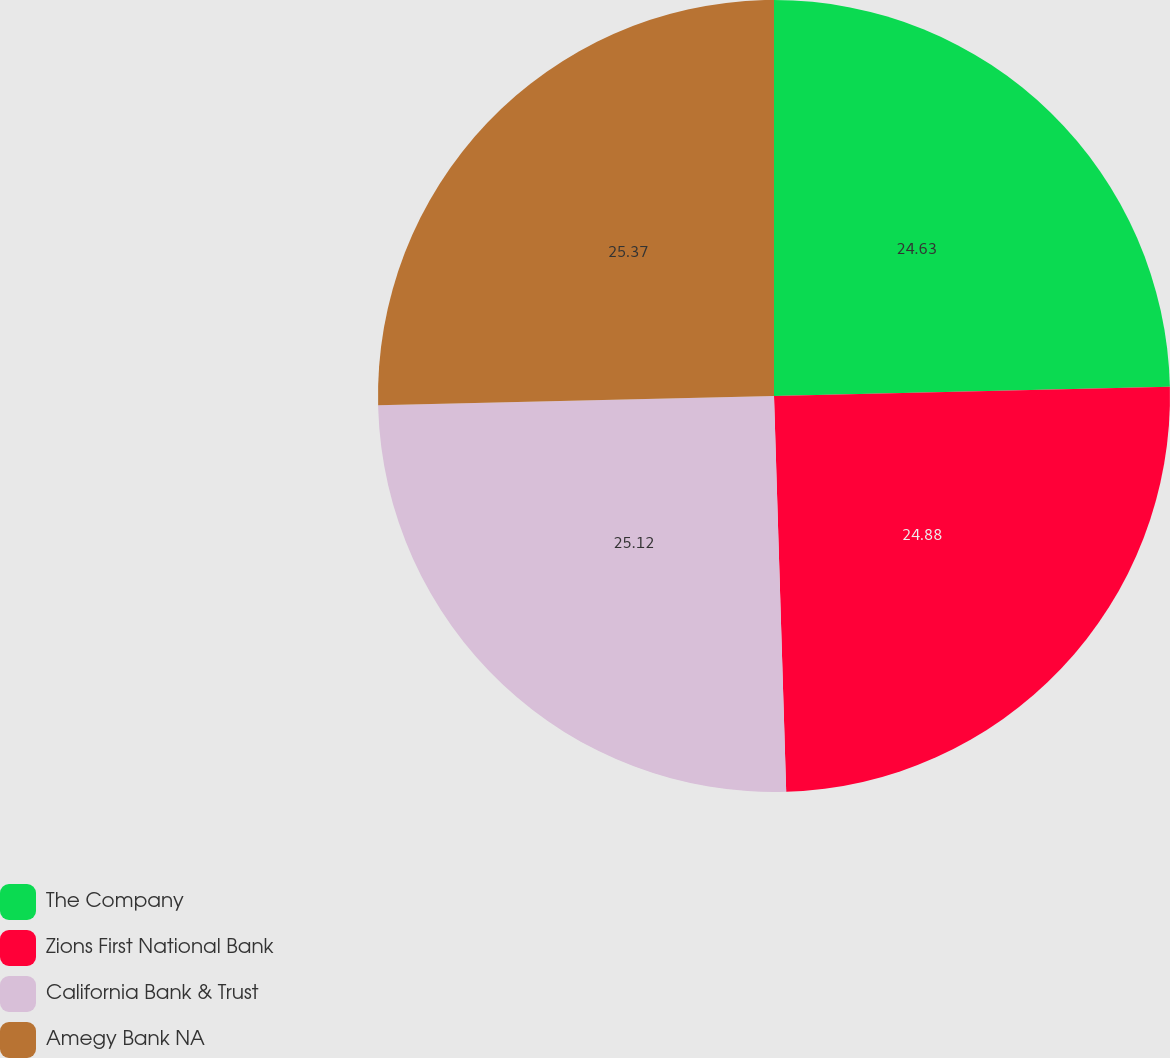Convert chart. <chart><loc_0><loc_0><loc_500><loc_500><pie_chart><fcel>The Company<fcel>Zions First National Bank<fcel>California Bank & Trust<fcel>Amegy Bank NA<nl><fcel>24.63%<fcel>24.88%<fcel>25.12%<fcel>25.37%<nl></chart> 